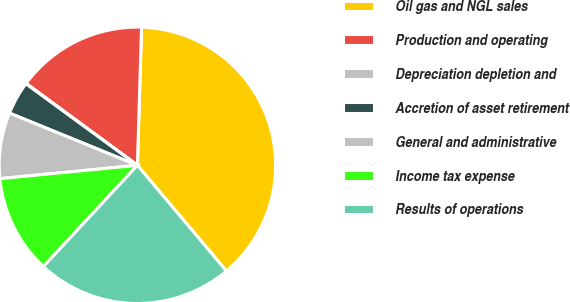Convert chart to OTSL. <chart><loc_0><loc_0><loc_500><loc_500><pie_chart><fcel>Oil gas and NGL sales<fcel>Production and operating<fcel>Depreciation depletion and<fcel>Accretion of asset retirement<fcel>General and administrative<fcel>Income tax expense<fcel>Results of operations<nl><fcel>38.38%<fcel>15.38%<fcel>0.05%<fcel>3.88%<fcel>7.71%<fcel>11.55%<fcel>23.05%<nl></chart> 